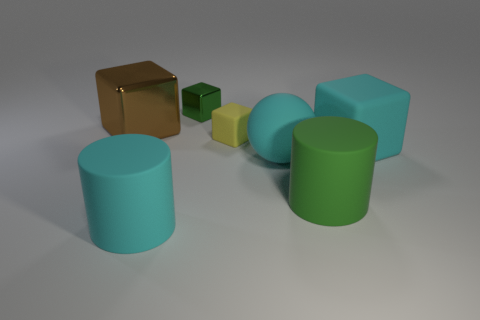Is there anything else that has the same size as the yellow block?
Give a very brief answer. Yes. What number of other objects are the same material as the green cube?
Your answer should be compact. 1. What is the material of the large cyan cube?
Your answer should be compact. Rubber. What size is the green object that is in front of the large brown object?
Provide a succinct answer. Large. There is a small yellow thing that is right of the big brown metal block; how many big objects are to the left of it?
Your response must be concise. 2. Does the big matte object that is right of the big green rubber object have the same shape as the large thing that is behind the yellow rubber object?
Give a very brief answer. Yes. How many blocks are behind the large cyan block and in front of the large brown cube?
Ensure brevity in your answer.  1. Is there a big object of the same color as the rubber sphere?
Your answer should be compact. Yes. There is a brown thing that is the same size as the green cylinder; what is its shape?
Offer a very short reply. Cube. There is a big green matte object; are there any cyan rubber objects behind it?
Give a very brief answer. Yes. 